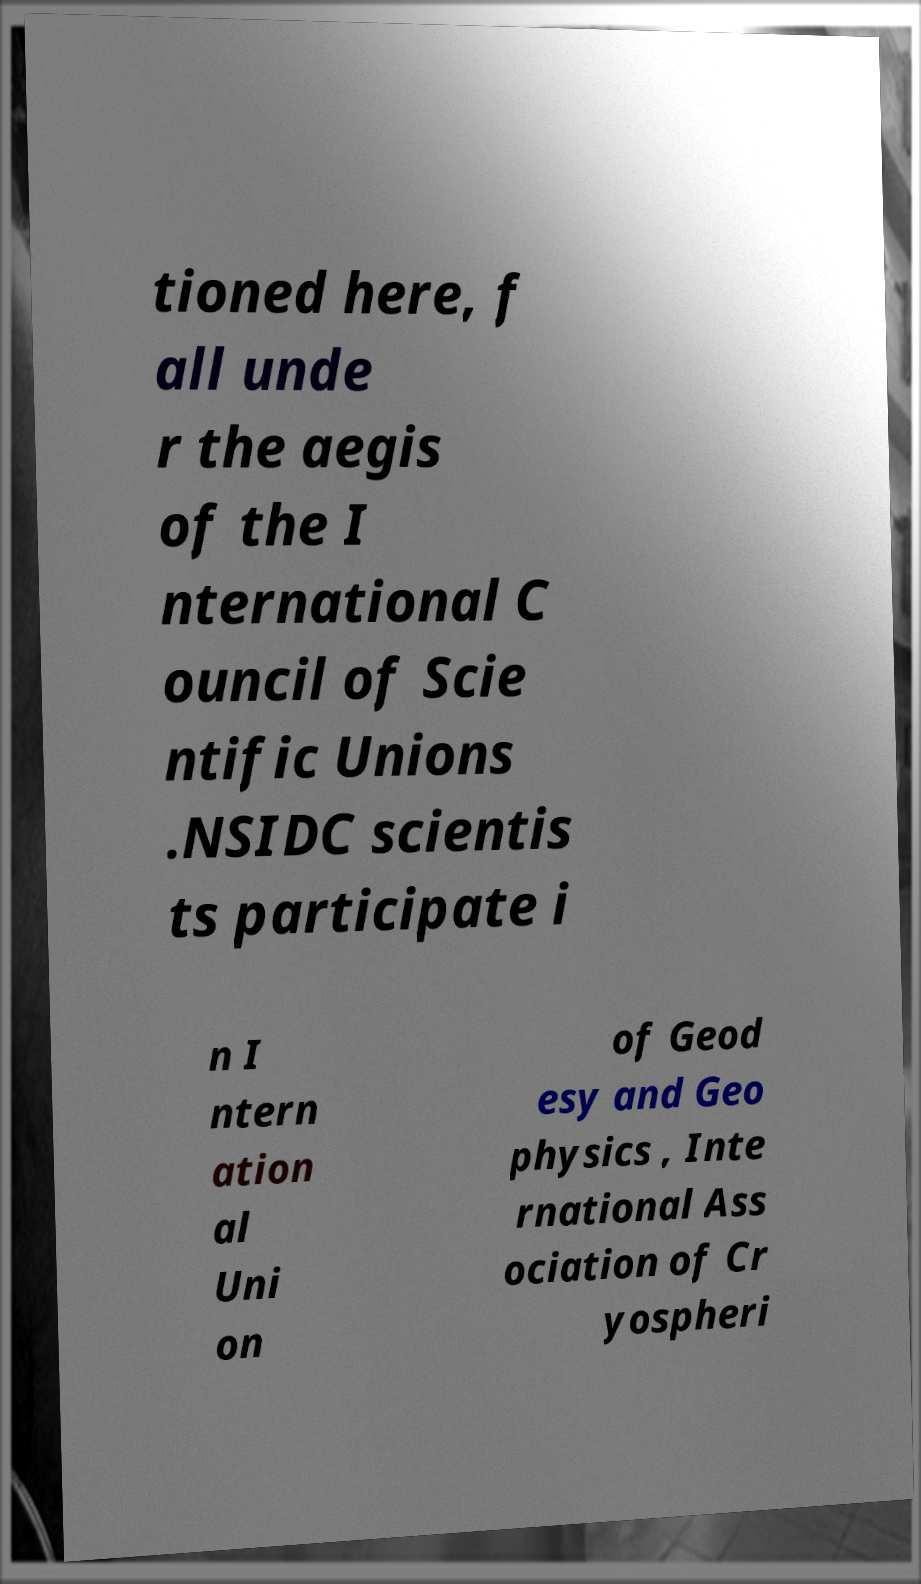Could you extract and type out the text from this image? tioned here, f all unde r the aegis of the I nternational C ouncil of Scie ntific Unions .NSIDC scientis ts participate i n I ntern ation al Uni on of Geod esy and Geo physics , Inte rnational Ass ociation of Cr yospheri 